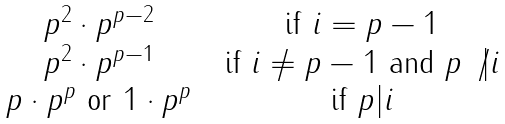<formula> <loc_0><loc_0><loc_500><loc_500>\begin{matrix} p ^ { 2 } \cdot p ^ { p - 2 } & & \text {if $i = p-1$} \\ p ^ { 2 } \cdot p ^ { p - 1 } & & \text {if $i \neq p-1$ and $p \not| i$} \\ p \cdot p ^ { p } \text { or } 1 \cdot p ^ { p } & & \text {if $p | i$} \end{matrix}</formula> 